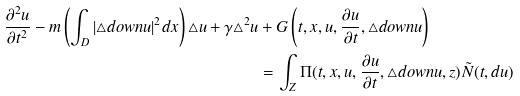<formula> <loc_0><loc_0><loc_500><loc_500>\frac { \partial ^ { 2 } u } { \partial t ^ { 2 } } - m \left ( \int _ { D } | \triangle d o w n u | ^ { 2 } d x \right ) \triangle u + \gamma \triangle ^ { 2 } u & + G \left ( t , x , u , \frac { \partial u } { \partial t } , \triangle d o w n u \right ) \\ & = \int _ { Z } \Pi ( t , x , u , \frac { \partial u } { \partial t } , \triangle d o w n u , z ) \tilde { N } ( t , d u )</formula> 